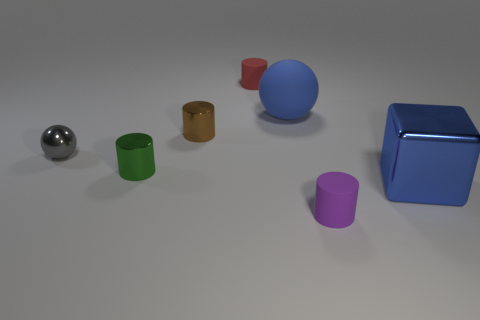Subtract all brown cylinders. How many cylinders are left? 3 Add 3 rubber cylinders. How many objects exist? 10 Subtract 1 cubes. How many cubes are left? 0 Subtract all gray balls. How many balls are left? 1 Subtract all cylinders. How many objects are left? 3 Add 1 large shiny objects. How many large shiny objects are left? 2 Add 6 large purple matte blocks. How many large purple matte blocks exist? 6 Subtract 1 green cylinders. How many objects are left? 6 Subtract all yellow spheres. Subtract all red cubes. How many spheres are left? 2 Subtract all big red rubber spheres. Subtract all green objects. How many objects are left? 6 